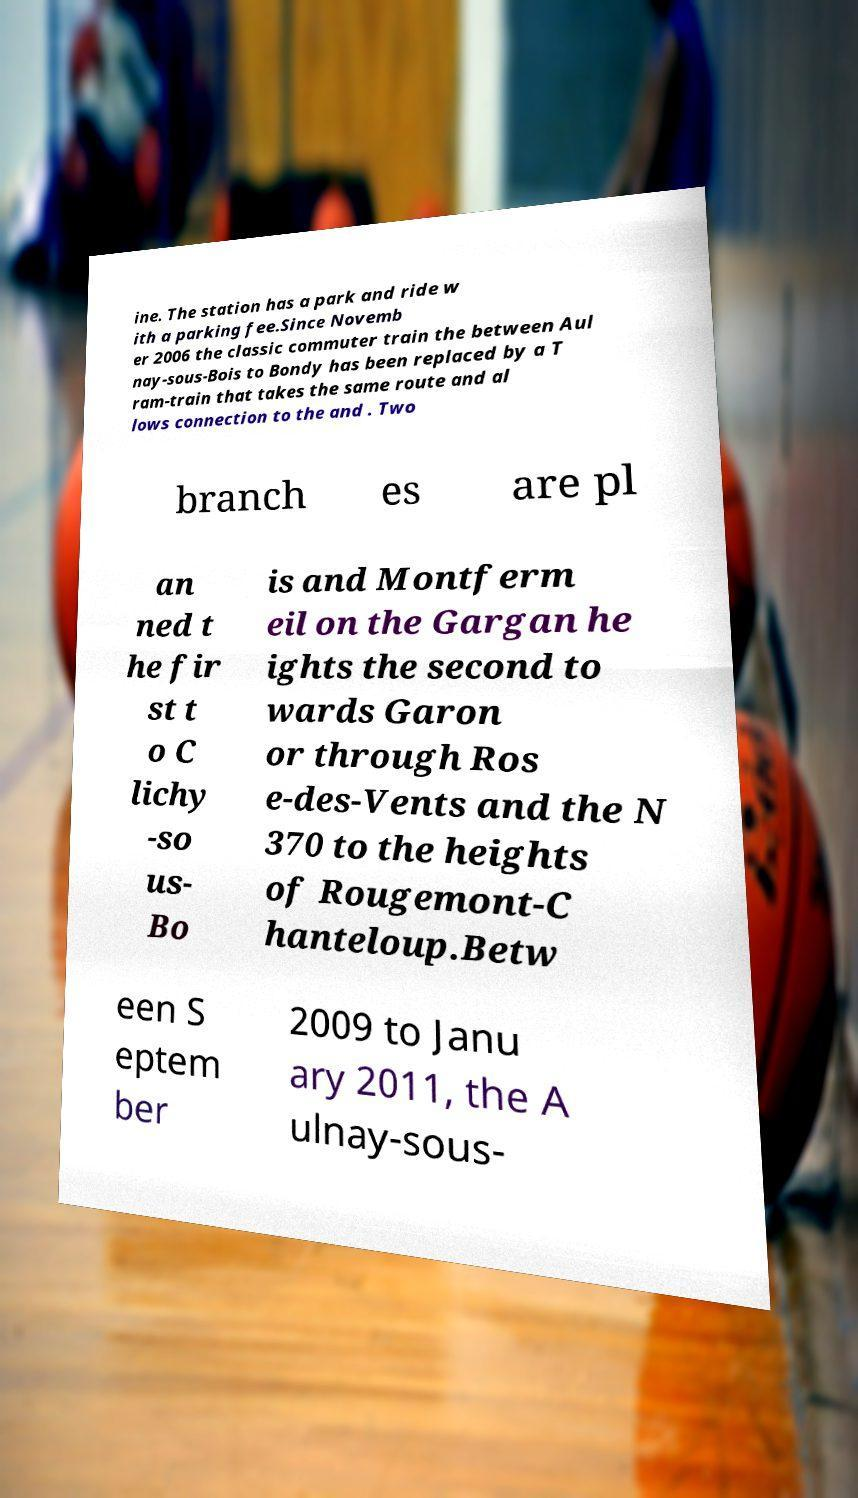There's text embedded in this image that I need extracted. Can you transcribe it verbatim? ine. The station has a park and ride w ith a parking fee.Since Novemb er 2006 the classic commuter train the between Aul nay-sous-Bois to Bondy has been replaced by a T ram-train that takes the same route and al lows connection to the and . Two branch es are pl an ned t he fir st t o C lichy -so us- Bo is and Montferm eil on the Gargan he ights the second to wards Garon or through Ros e-des-Vents and the N 370 to the heights of Rougemont-C hanteloup.Betw een S eptem ber 2009 to Janu ary 2011, the A ulnay-sous- 